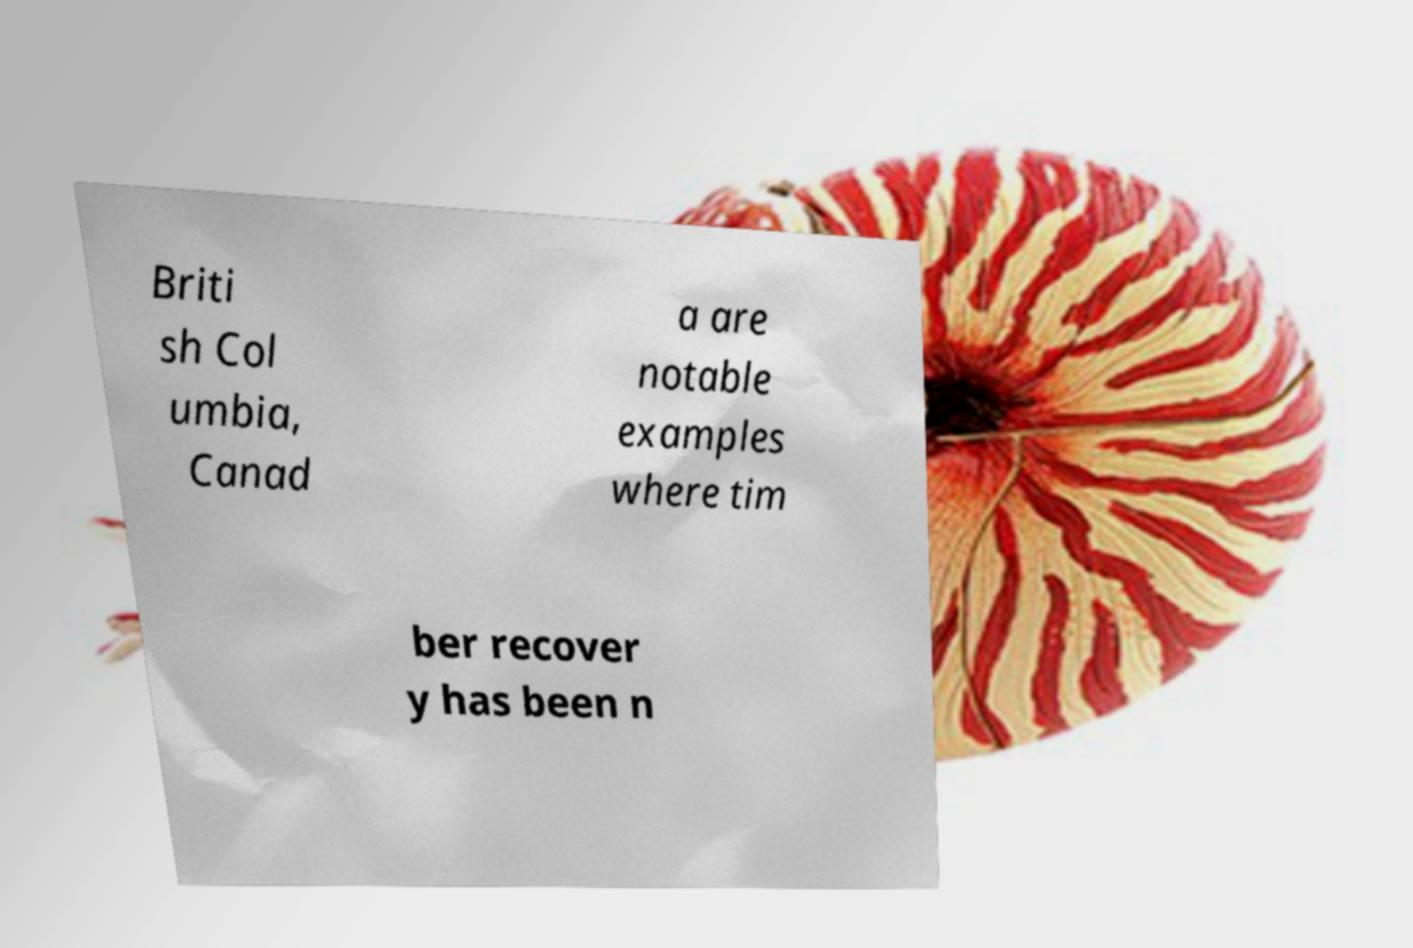What messages or text are displayed in this image? I need them in a readable, typed format. Briti sh Col umbia, Canad a are notable examples where tim ber recover y has been n 